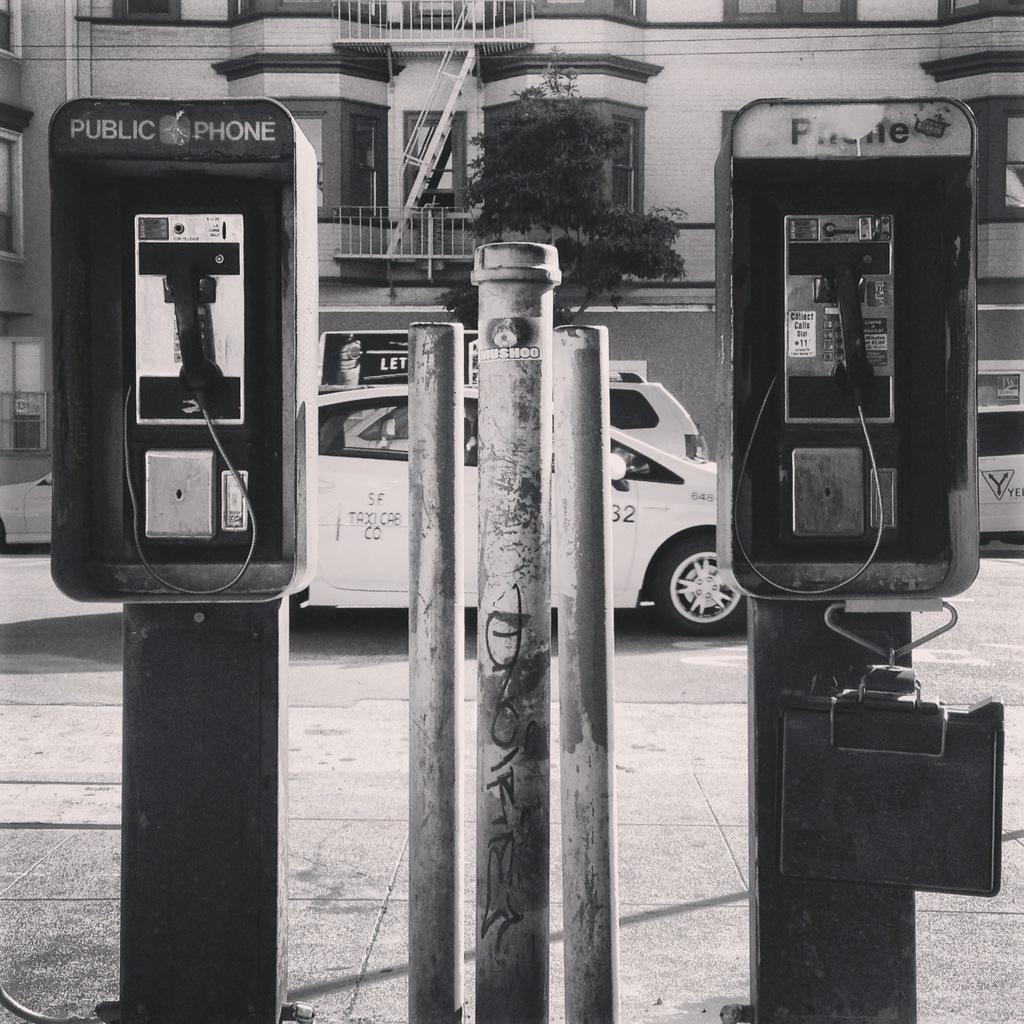Can you describe this image briefly? This is black and white image, in this image there are public phones in the middle there is a pole, in the background there are cars on road and buildings and trees. 